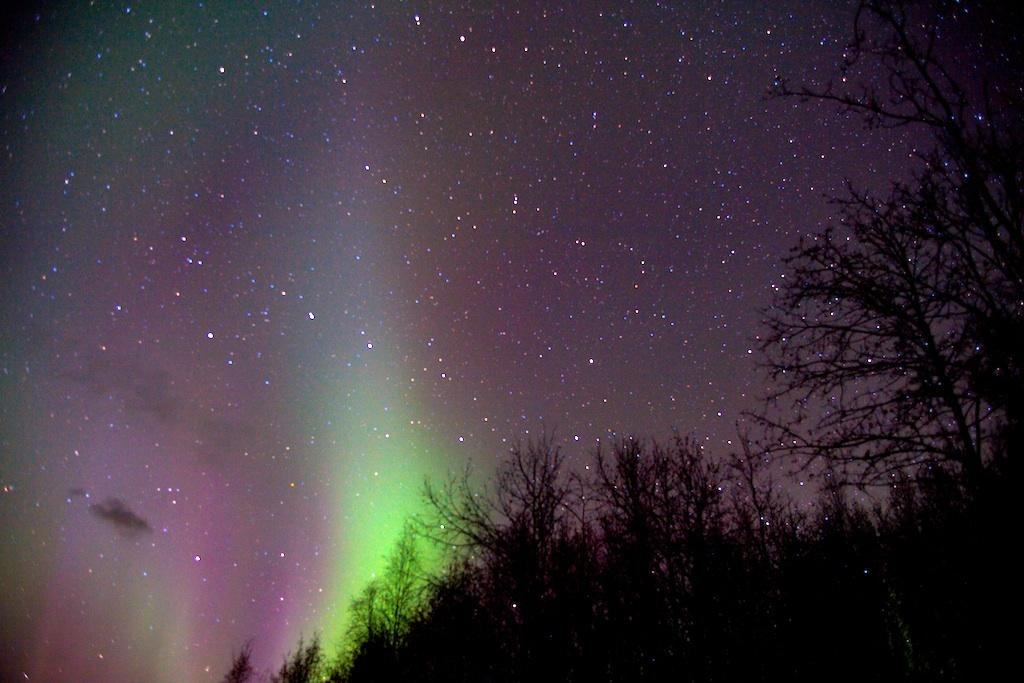What type of vegetation is present in the image? There is a group of trees in the image. What can be seen in the sky in the image? Stars are visible in the sky in the image. How many pages are included in the image? There are no pages present in the image; it features a group of trees and stars visible in the sky. What type of sponge is used to clean the trees in the image? There is no sponge present in the image, and trees do not require cleaning with a sponge. 